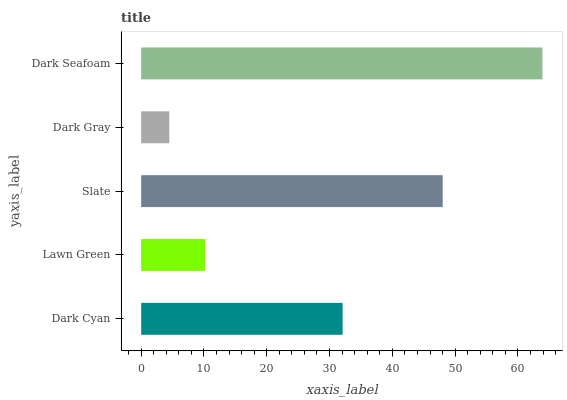Is Dark Gray the minimum?
Answer yes or no. Yes. Is Dark Seafoam the maximum?
Answer yes or no. Yes. Is Lawn Green the minimum?
Answer yes or no. No. Is Lawn Green the maximum?
Answer yes or no. No. Is Dark Cyan greater than Lawn Green?
Answer yes or no. Yes. Is Lawn Green less than Dark Cyan?
Answer yes or no. Yes. Is Lawn Green greater than Dark Cyan?
Answer yes or no. No. Is Dark Cyan less than Lawn Green?
Answer yes or no. No. Is Dark Cyan the high median?
Answer yes or no. Yes. Is Dark Cyan the low median?
Answer yes or no. Yes. Is Dark Seafoam the high median?
Answer yes or no. No. Is Slate the low median?
Answer yes or no. No. 